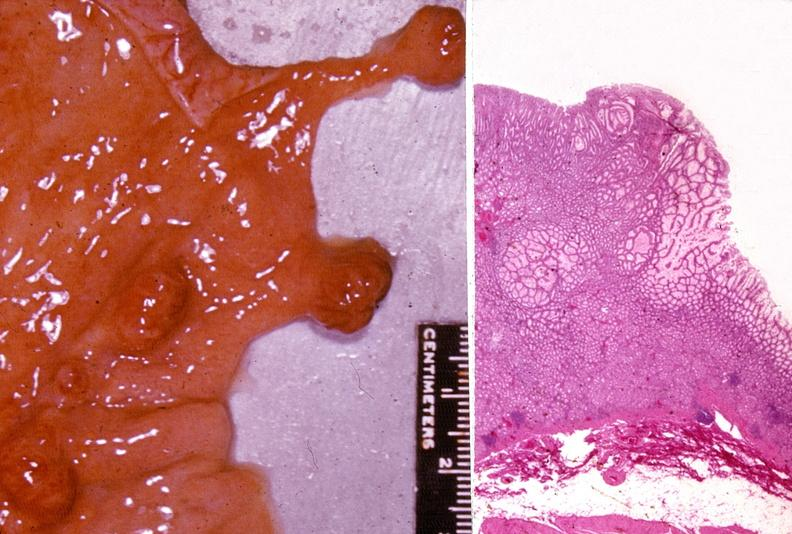s gastrointestinal present?
Answer the question using a single word or phrase. Yes 